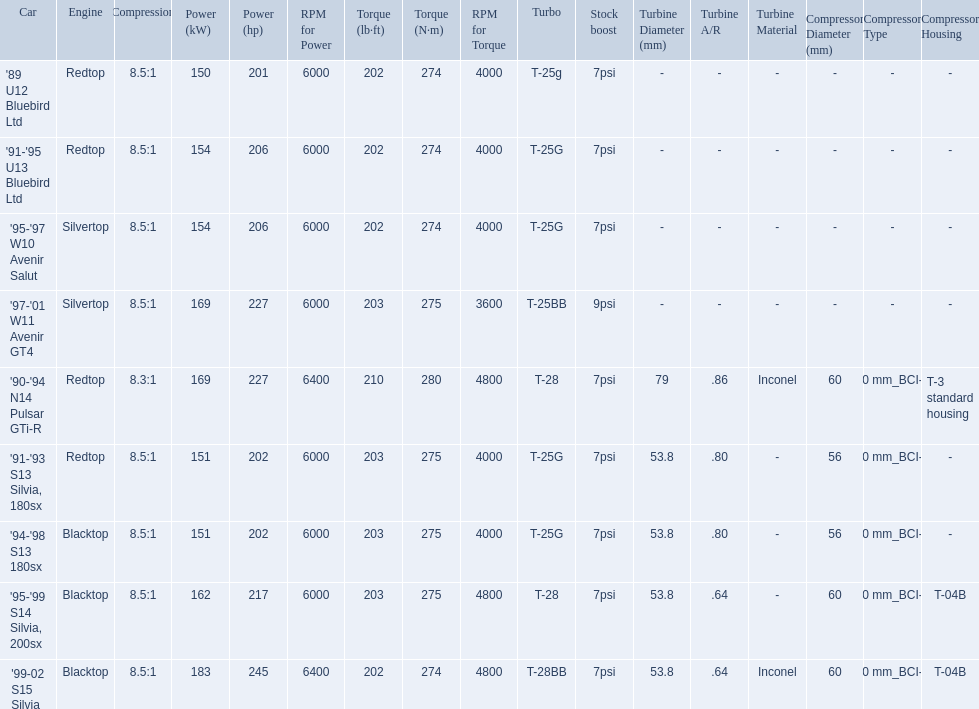What are all the cars? '89 U12 Bluebird Ltd, '91-'95 U13 Bluebird Ltd, '95-'97 W10 Avenir Salut, '97-'01 W11 Avenir GT4, '90-'94 N14 Pulsar GTi-R, '91-'93 S13 Silvia, 180sx, '94-'98 S13 180sx, '95-'99 S14 Silvia, 200sx, '99-02 S15 Silvia. What are their stock boosts? 7psi, 7psi, 7psi, 9psi, 7psi, 7psi, 7psi, 7psi, 7psi. And which car has the highest stock boost? '97-'01 W11 Avenir GT4. 